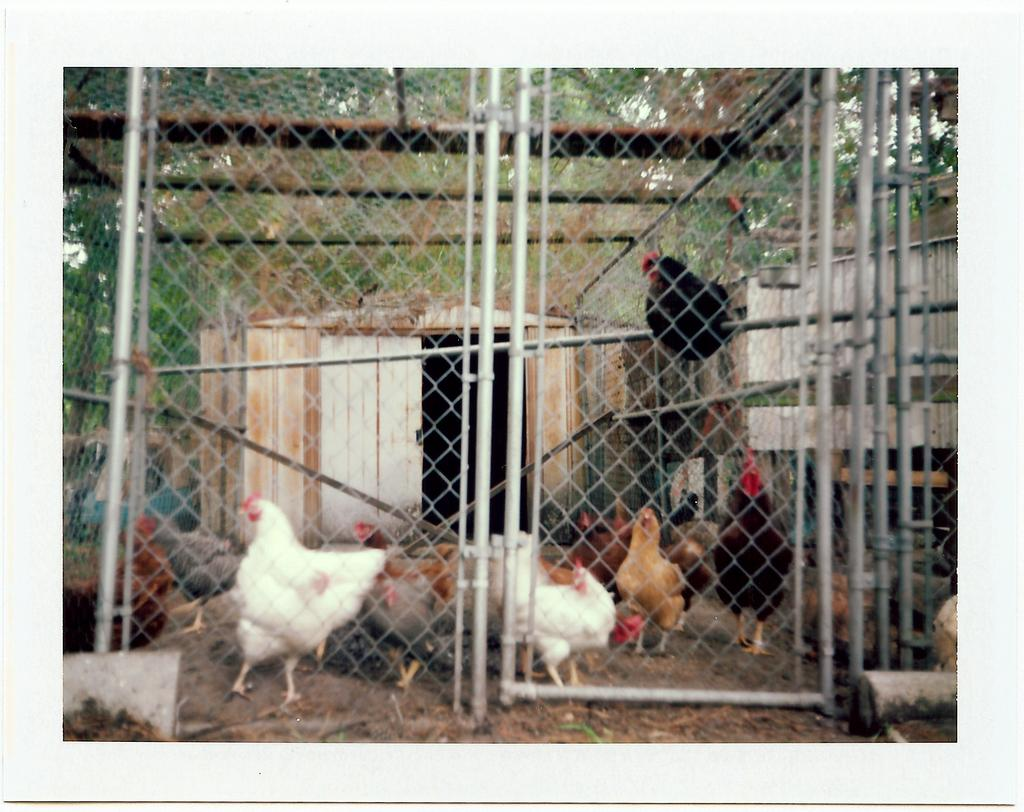What animals can be seen on the ground in the image? There are hens on the ground in the image. What is used to enclose the hens in the image? There is a net fencing around the hens in the image. What structure can be seen in the background of the image? There is a shed in the background of the image. What type of vegetation is visible in the background of the image? There are trees in the background of the image. What type of juice is being served by the band in the image? There is no band or juice present in the image; it features hens on the ground with net fencing and a shed in the background. 